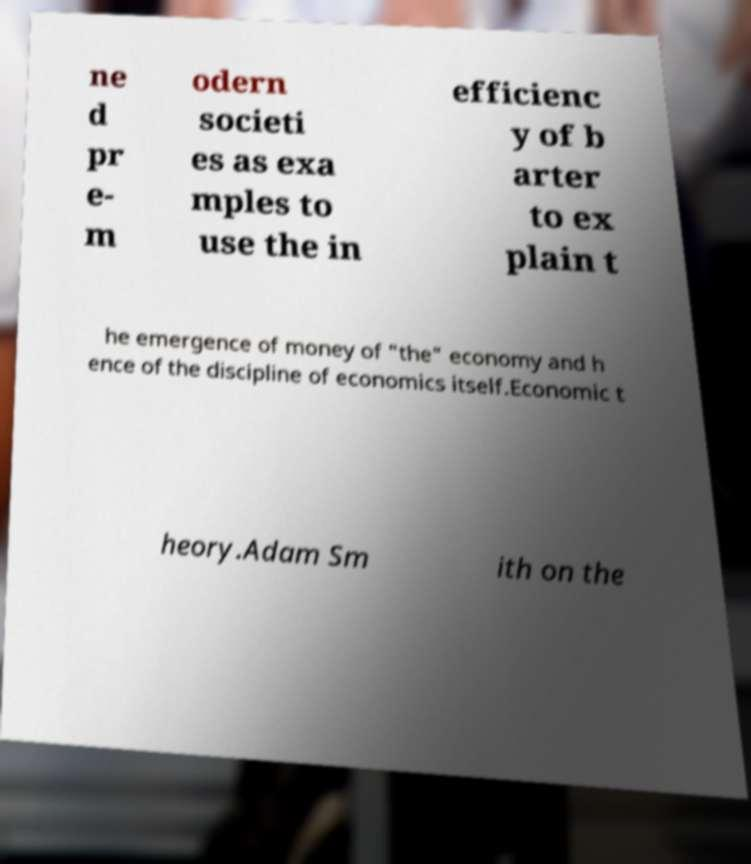Can you read and provide the text displayed in the image?This photo seems to have some interesting text. Can you extract and type it out for me? ne d pr e- m odern societi es as exa mples to use the in efficienc y of b arter to ex plain t he emergence of money of "the" economy and h ence of the discipline of economics itself.Economic t heory.Adam Sm ith on the 